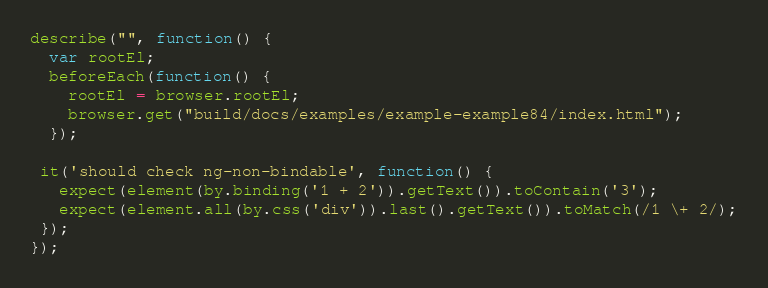<code> <loc_0><loc_0><loc_500><loc_500><_JavaScript_>describe("", function() {
  var rootEl;
  beforeEach(function() {
    rootEl = browser.rootEl;
    browser.get("build/docs/examples/example-example84/index.html");
  });
  
 it('should check ng-non-bindable', function() {
   expect(element(by.binding('1 + 2')).getText()).toContain('3');
   expect(element.all(by.css('div')).last().getText()).toMatch(/1 \+ 2/);
 });
});</code> 